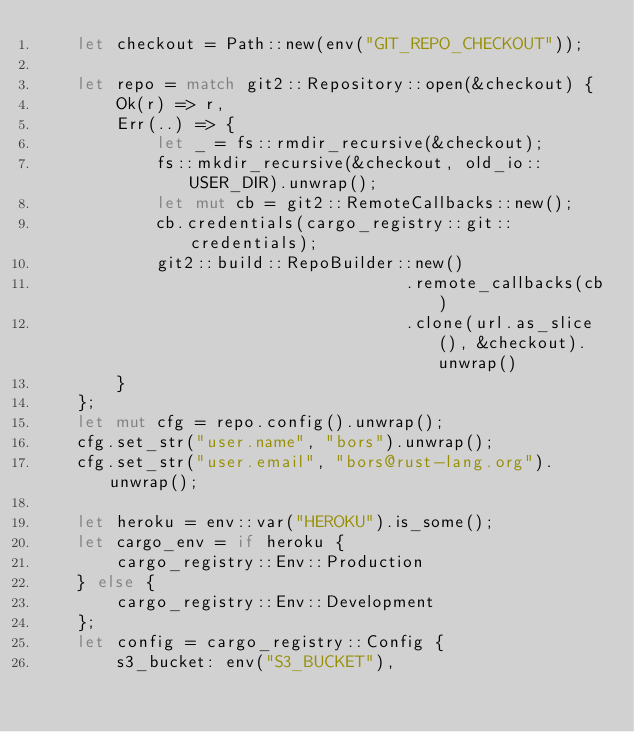<code> <loc_0><loc_0><loc_500><loc_500><_Rust_>    let checkout = Path::new(env("GIT_REPO_CHECKOUT"));

    let repo = match git2::Repository::open(&checkout) {
        Ok(r) => r,
        Err(..) => {
            let _ = fs::rmdir_recursive(&checkout);
            fs::mkdir_recursive(&checkout, old_io::USER_DIR).unwrap();
            let mut cb = git2::RemoteCallbacks::new();
            cb.credentials(cargo_registry::git::credentials);
            git2::build::RepoBuilder::new()
                                     .remote_callbacks(cb)
                                     .clone(url.as_slice(), &checkout).unwrap()
        }
    };
    let mut cfg = repo.config().unwrap();
    cfg.set_str("user.name", "bors").unwrap();
    cfg.set_str("user.email", "bors@rust-lang.org").unwrap();

    let heroku = env::var("HEROKU").is_some();
    let cargo_env = if heroku {
        cargo_registry::Env::Production
    } else {
        cargo_registry::Env::Development
    };
    let config = cargo_registry::Config {
        s3_bucket: env("S3_BUCKET"),</code> 